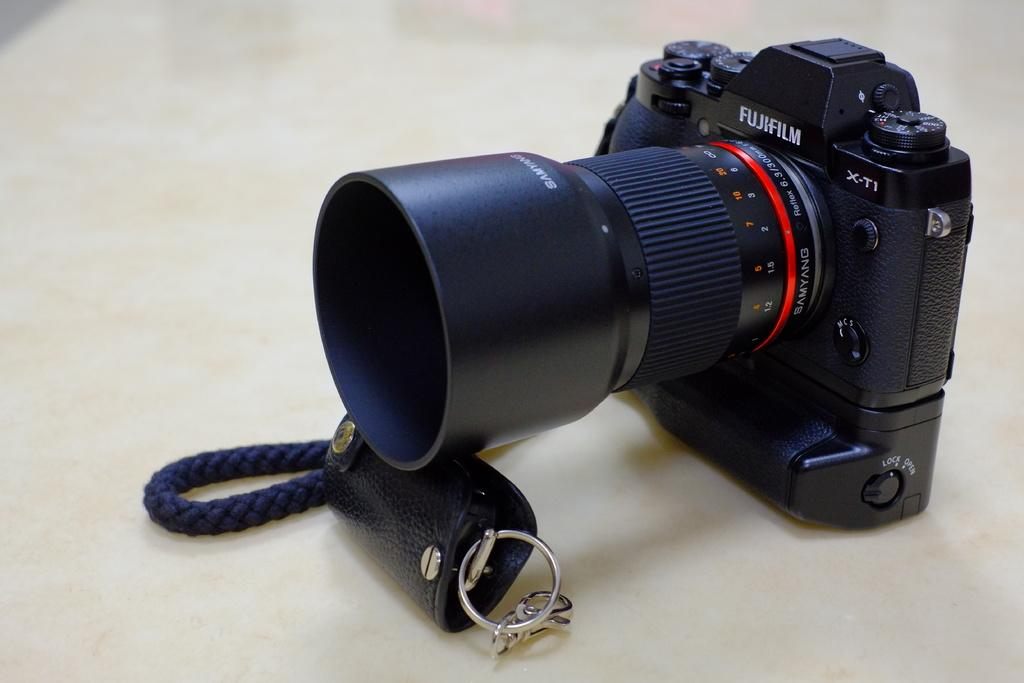<image>
Summarize the visual content of the image. Black, white, and red fugifilm camera with reflex 